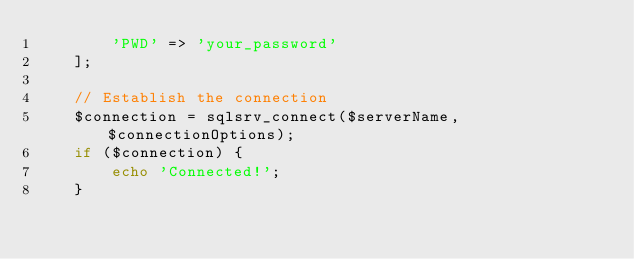Convert code to text. <code><loc_0><loc_0><loc_500><loc_500><_PHP_>        'PWD' => 'your_password'
    ];

    // Establish the connection
    $connection = sqlsrv_connect($serverName, $connectionOptions);
    if ($connection) {
        echo 'Connected!';
    }
</code> 